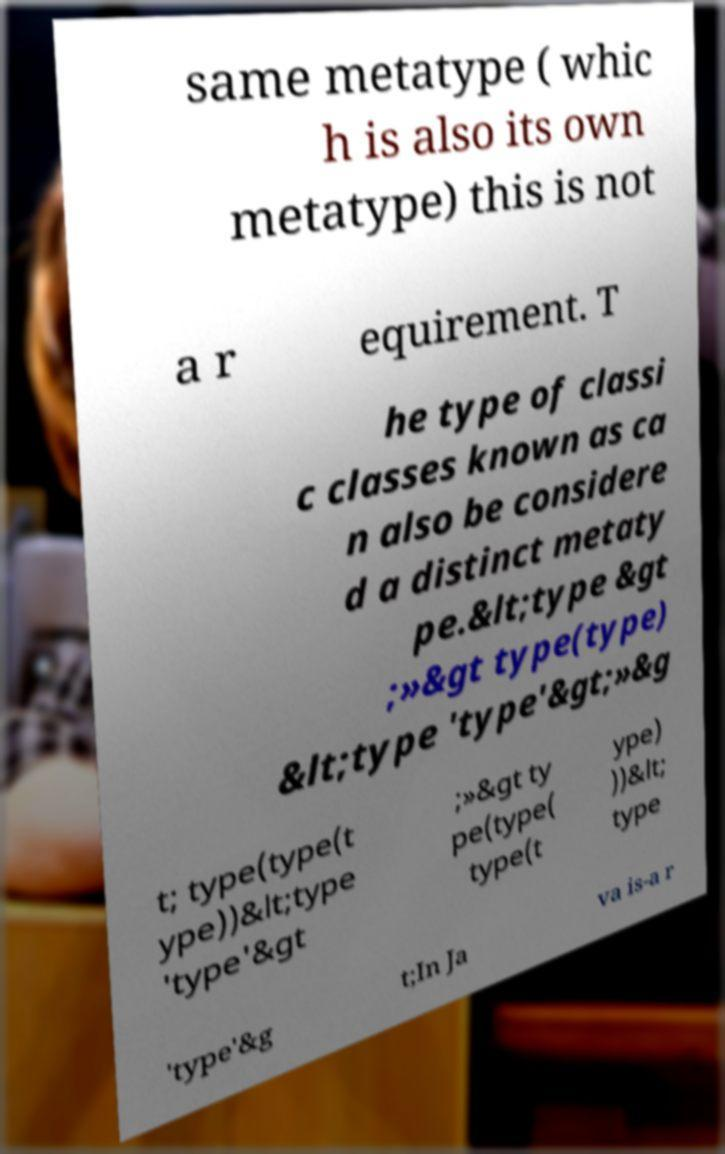Could you assist in decoding the text presented in this image and type it out clearly? same metatype ( whic h is also its own metatype) this is not a r equirement. T he type of classi c classes known as ca n also be considere d a distinct metaty pe.&lt;type &gt ;»&gt type(type) &lt;type 'type'&gt;»&g t; type(type(t ype))&lt;type 'type'&gt ;»&gt ty pe(type( type(t ype) ))&lt; type 'type'&g t;In Ja va is-a r 